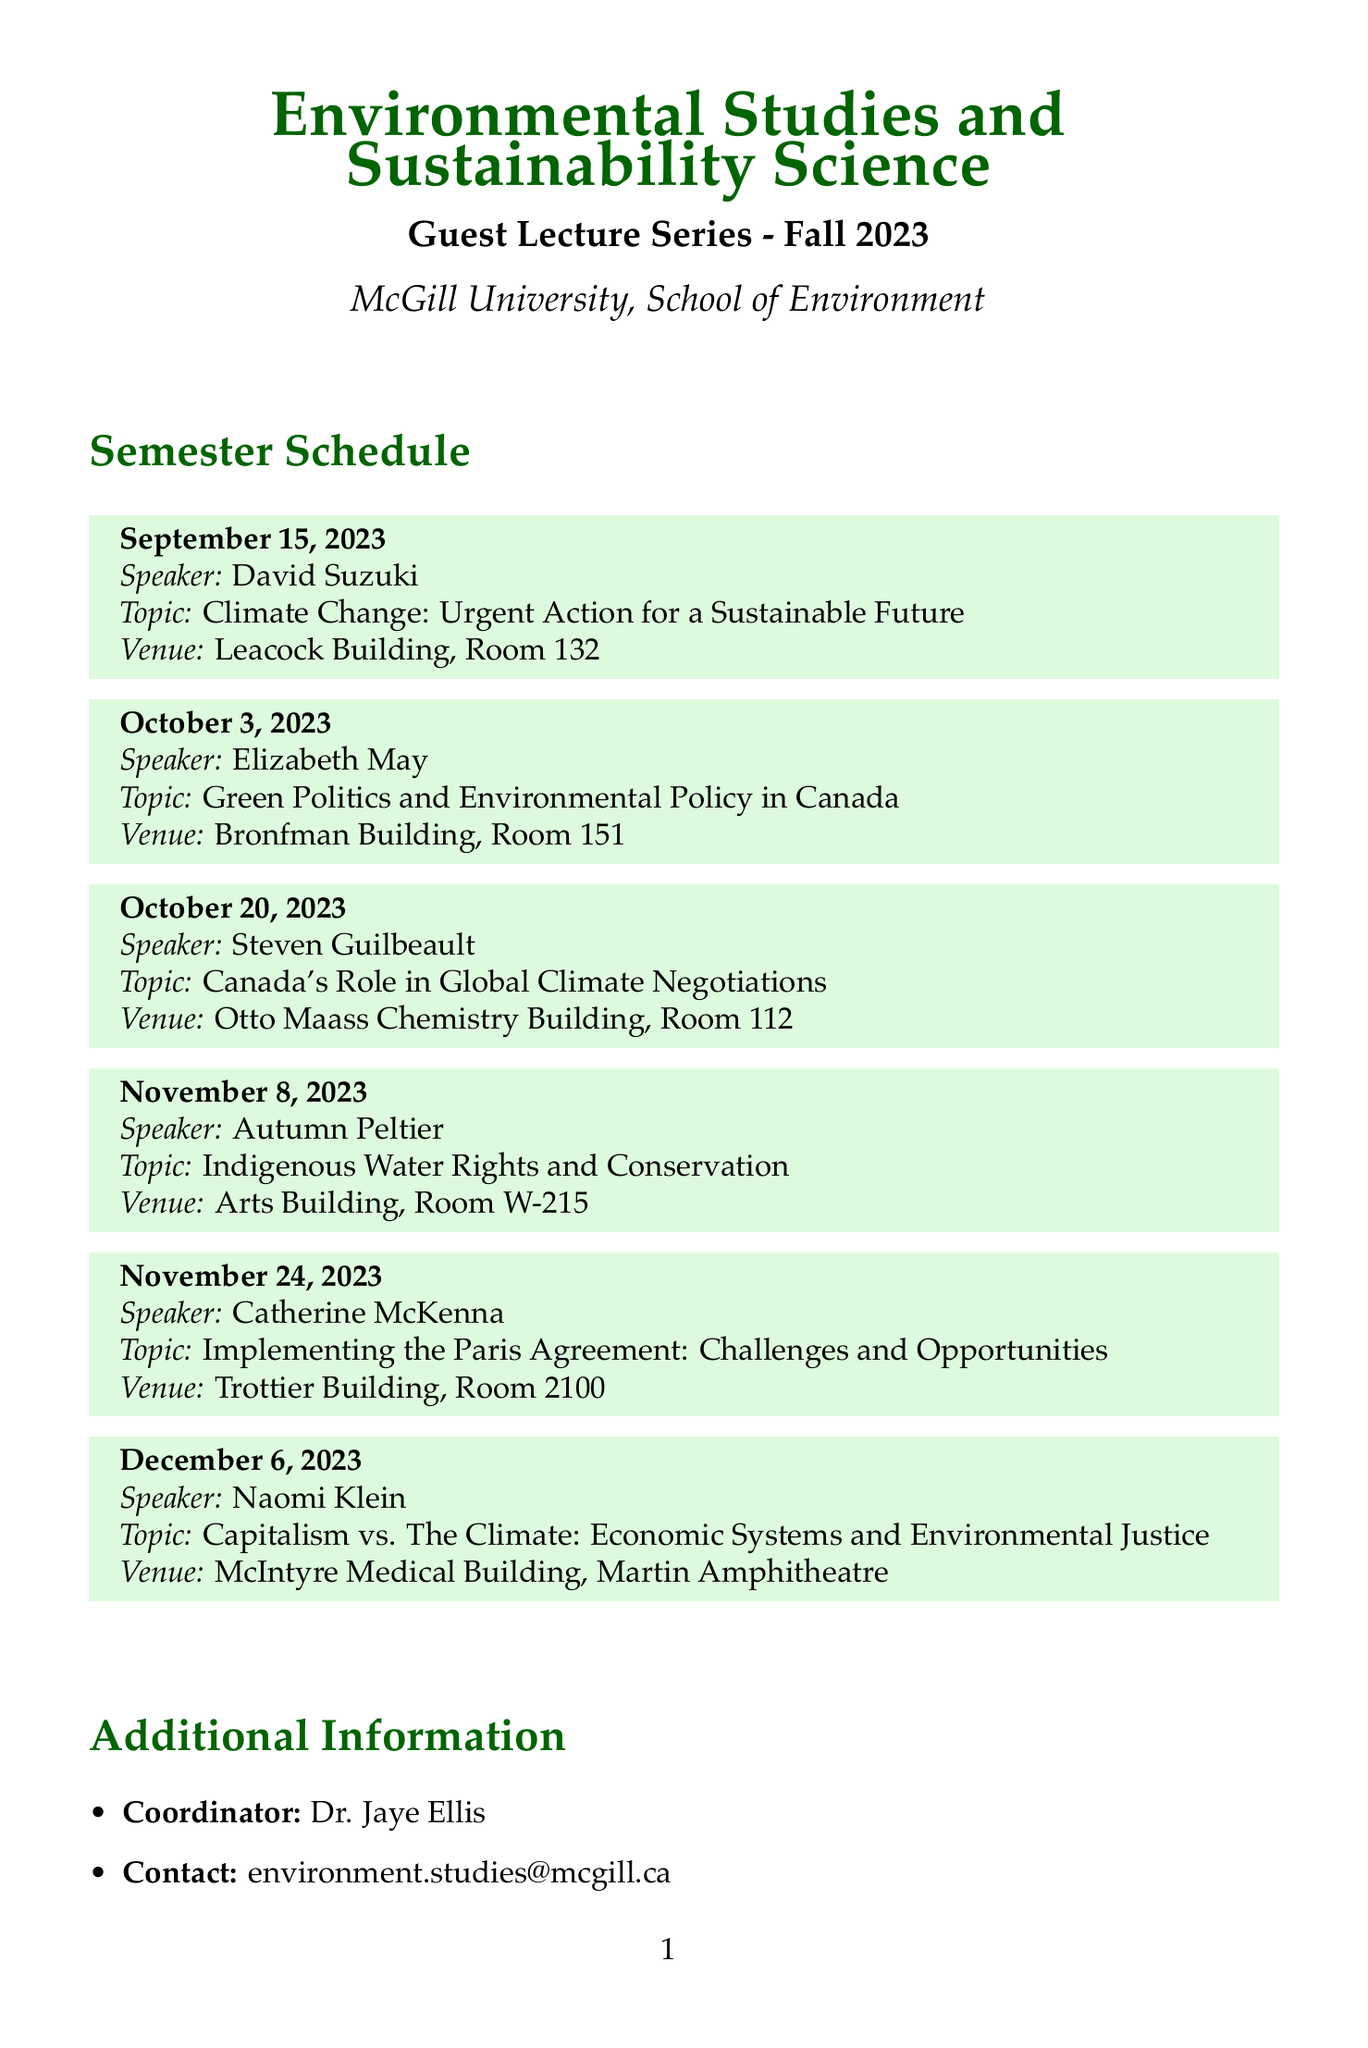what is the date of the first guest lecture? The date of the first guest lecture is the earliest one listed in the schedule, which is September 15, 2023.
Answer: September 15, 2023 who is the speaker on October 20, 2023? The speaker for the lecture on October 20, 2023 is listed next to that date, which is Steven Guilbeault.
Answer: Steven Guilbeault what is the topic of the lecture by Naomi Klein? The document states the topic of Naomi Klein's lecture directly, which is about economic systems and environmental justice.
Answer: Capitalism vs. The Climate: Economic Systems and Environmental Justice which venue will host Elizabeth May's lecture? The specific venue for Elizabeth May's lecture can be found next to her name in the schedule, which is Bronfman Building, Room 151.
Answer: Bronfman Building, Room 151 how many guest lectures are scheduled for Fall 2023? Counting the entries listed under the guest lectures section provides the total number of lectures planned.
Answer: 6 what role does Dr. Jaye Ellis have in this event? The document indicates Dr. Jaye Ellis' position regarding the guest lecture series, which is as the coordinator.
Answer: Coordinator are the guest lectures open to the public? There is a specific point in the document that confirms this information about accessibility for the lectures.
Answer: Yes what is the time for the study group meetings? The time for the study group meetings is detailed in the personal notes section of the document.
Answer: Every Tuesday, 3:00 PM 